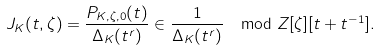Convert formula to latex. <formula><loc_0><loc_0><loc_500><loc_500>J _ { K } ( t , \zeta ) = \frac { P _ { K , \zeta , 0 } ( t ) } { \Delta _ { K } ( t ^ { r } ) } \in \frac { 1 } { \Delta _ { K } ( t ^ { r } ) } \mod Z [ \zeta ] [ t + t ^ { - 1 } ] .</formula> 